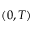Convert formula to latex. <formula><loc_0><loc_0><loc_500><loc_500>( 0 , T )</formula> 